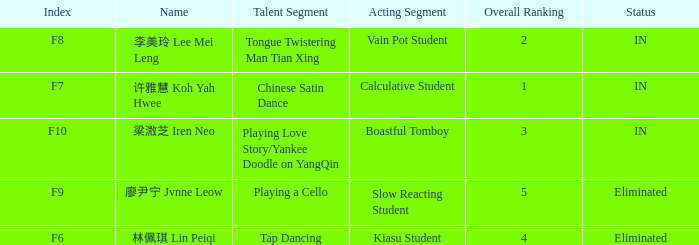For all events with index f10, what is the sum of the overall rankings? 3.0. 